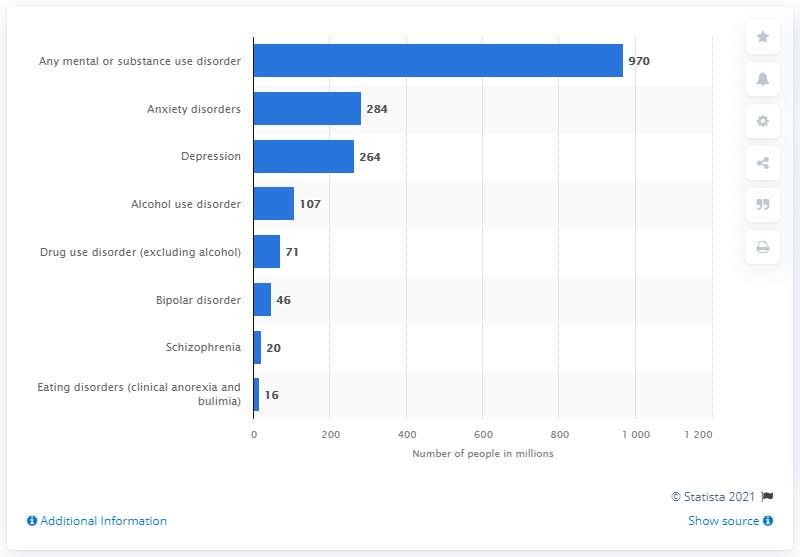List a handful of essential elements in this visual. As of 2017, it is estimated that approximately 284 million people worldwide were affected by anxiety. 